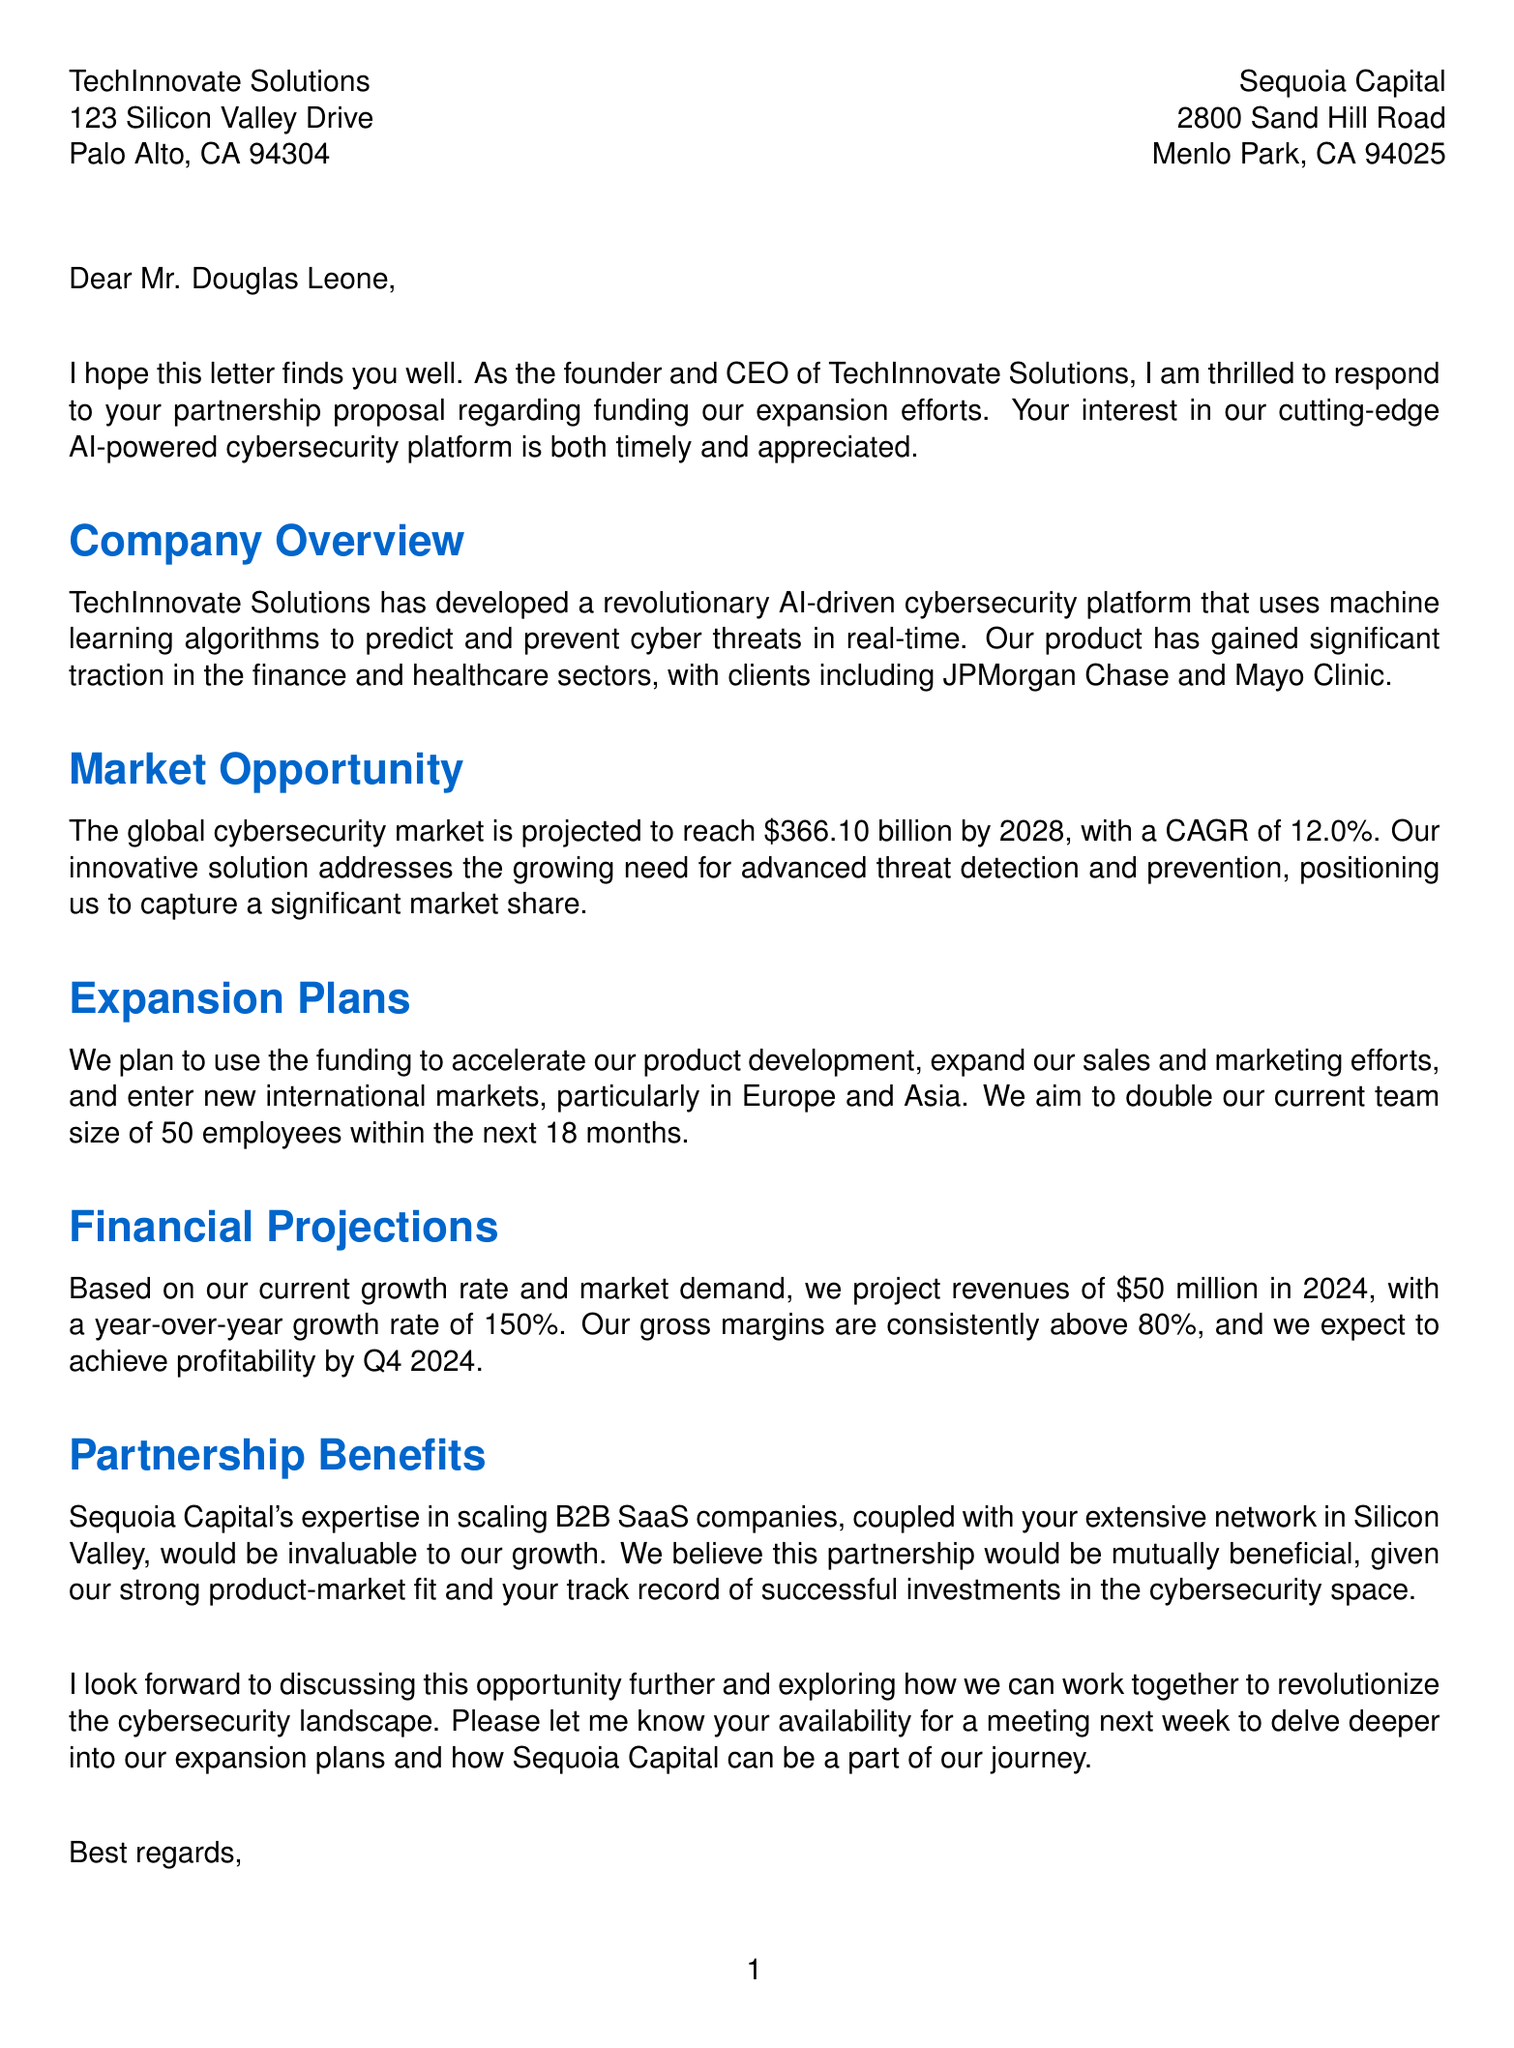what is the sender's name? The sender's name is mentioned in the signature section of the letter.
Answer: Sarah Chen what is the recipient's company name? The recipient's company name is found in the header of the document.
Answer: Sequoia Capital how much funding is being requested? The funding amount is specified in the additional information section of the document.
Answer: $50 million what percentage of equity is offered? The equity offered is listed in the additional information section.
Answer: 15% what is the projected revenue for 2024? The projected revenue can be found in the financial projections paragraph.
Answer: $50 million which sectors have shown significant traction? The sectors where the product has gained traction are mentioned in the company overview.
Answer: finance and healthcare who is the Chief Technology Officer? The name and position of the key team member is provided in the additional information.
Answer: Dr. Alex Rodriguez what is the competitive advantage of the company? The competitive advantage is described in the additional information section.
Answer: Proprietary AI algorithms with 99.9% accuracy in threat detection what are the plans for team expansion? The plans regarding team expansion are explained in the expansion plans section.
Answer: Double current team size within 18 months what meeting timeframe is suggested for further discussion? The timeframe for the meeting is mentioned in the closing paragraph of the letter.
Answer: Next week 